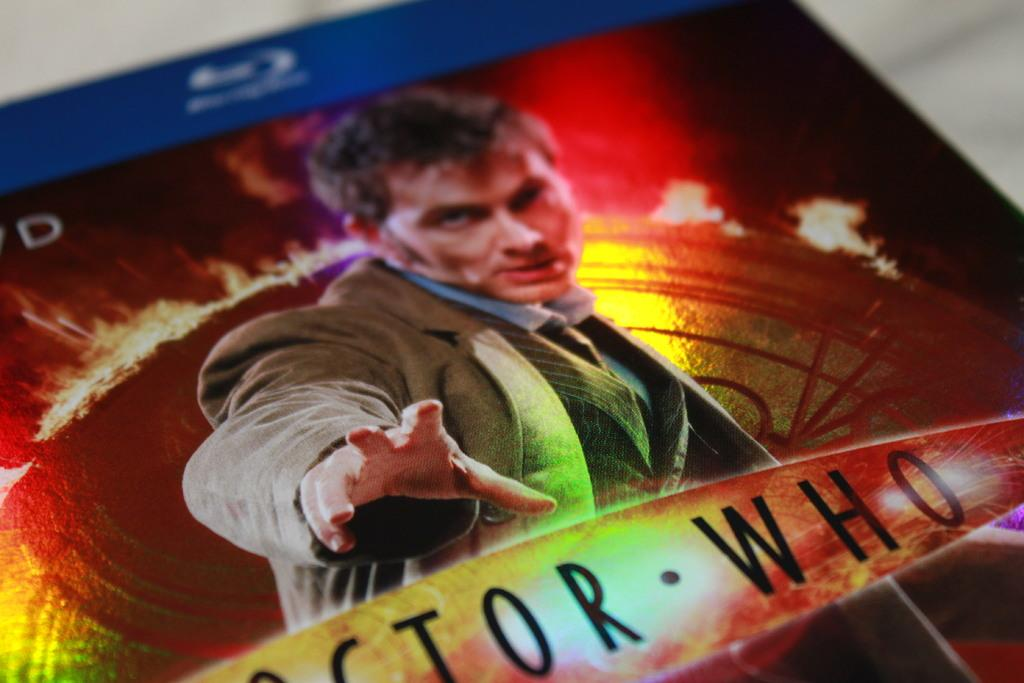<image>
Render a clear and concise summary of the photo. a book that has the title of Who on it 